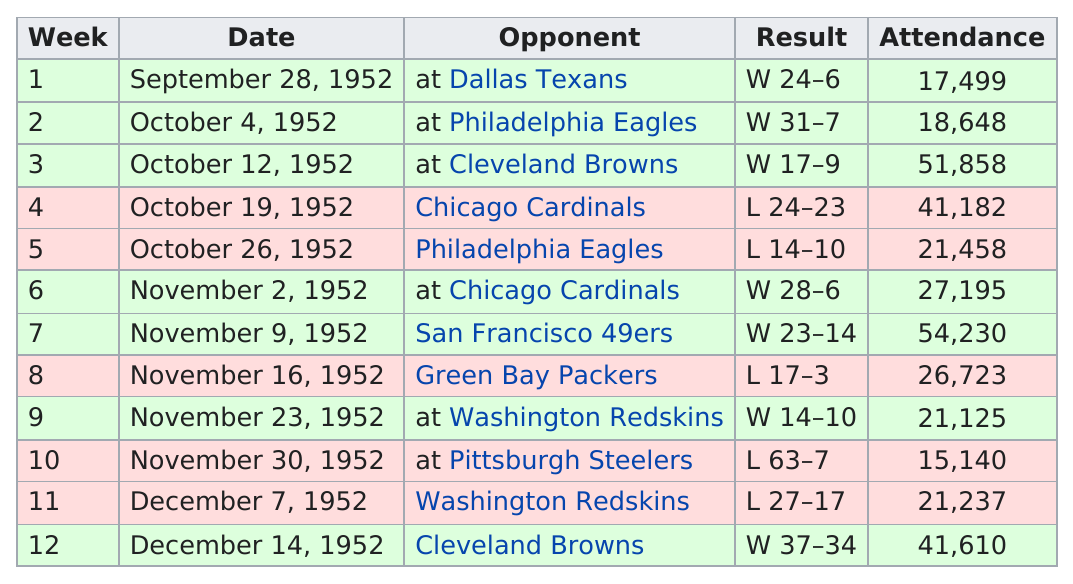Highlight a few significant elements in this photo. For how many consecutive games was attendance above 20,000? Seven. The longest winning streak was three games in a row. The average attendance for the games in December was 31,423.5. The only game that was lost and had attendance above 40,000 was on October 19, 1952. The attendance was higher during week 9 than during week 5. 